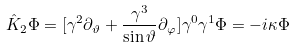Convert formula to latex. <formula><loc_0><loc_0><loc_500><loc_500>\hat { K } _ { 2 } \Phi = [ \gamma ^ { 2 } \partial _ { \vartheta } + \frac { \gamma ^ { 3 } } { \sin \vartheta } \partial _ { \varphi } ] \gamma ^ { 0 } \gamma ^ { 1 } \Phi = - i \kappa \Phi</formula> 